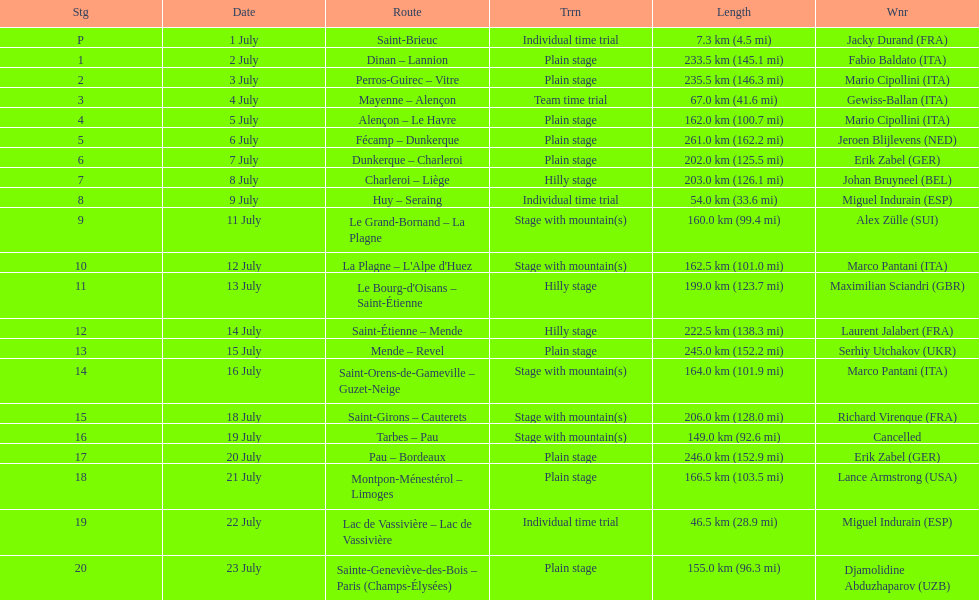After lance armstrong, who led next in the 1995 tour de france? Miguel Indurain. 